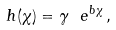<formula> <loc_0><loc_0><loc_500><loc_500>h ( \chi ) = \gamma \ e ^ { b \chi } \, ,</formula> 